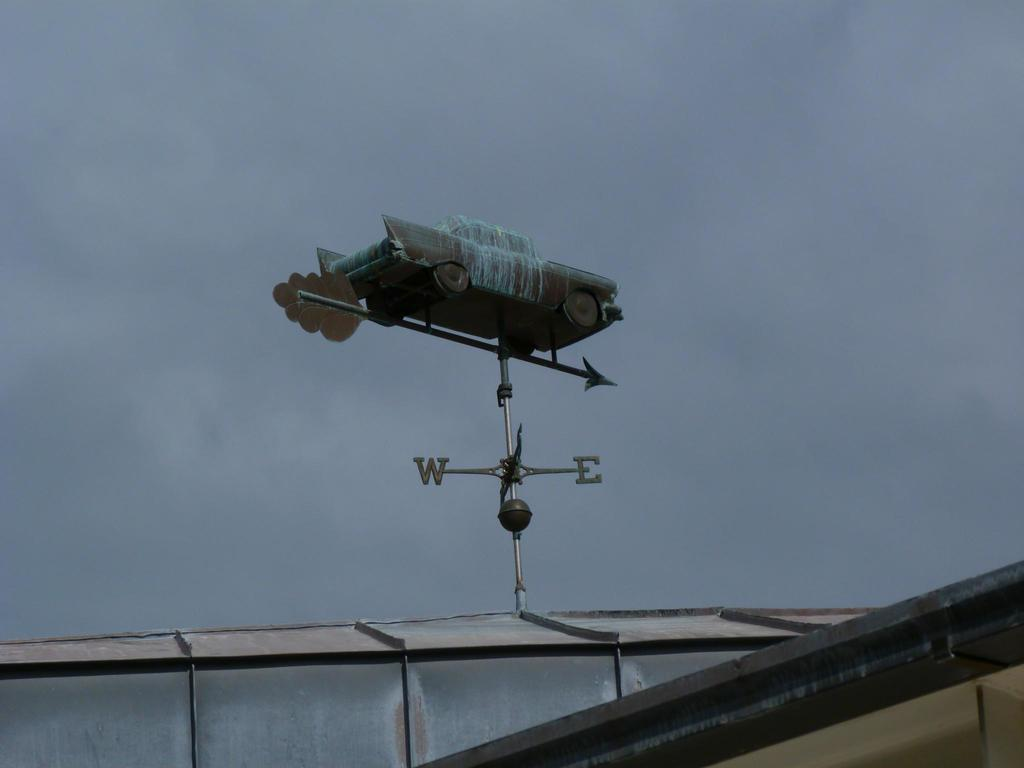<image>
Relay a brief, clear account of the picture shown. Compass pointing west or east with a car on it. 